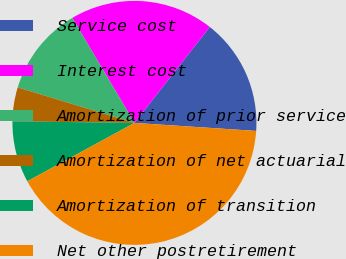Convert chart to OTSL. <chart><loc_0><loc_0><loc_500><loc_500><pie_chart><fcel>Service cost<fcel>Interest cost<fcel>Amortization of prior service<fcel>Amortization of net actuarial<fcel>Amortization of transition<fcel>Net other postretirement<nl><fcel>15.45%<fcel>19.1%<fcel>11.8%<fcel>4.49%<fcel>8.14%<fcel>41.01%<nl></chart> 